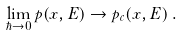<formula> <loc_0><loc_0><loc_500><loc_500>\lim _ { \hbar { \rightarrow } 0 } p ( x , E ) \rightarrow p _ { c } ( x , E ) \, .</formula> 